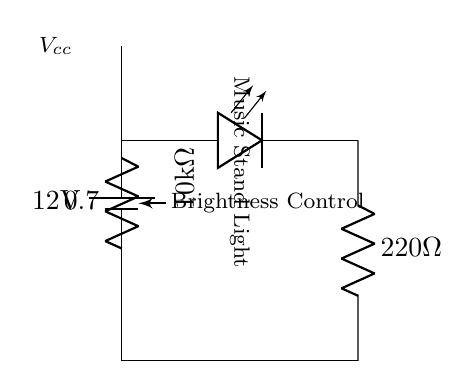What is the total voltage supplied to the circuit? The total voltage supplied to the circuit by the battery is indicated as 12 volts in the diagram.
Answer: 12 volts What type of component is used for brightness control? The component used for brightness control in this circuit is a potentiometer, specifically shown as a variable resistor, which allows adjustment of the current flowing to the LED.
Answer: Potentiometer What is the resistance value of the potentiometer? The resistance value of the potentiometer is labeled in the diagram as 10 kilo-ohms, indicating its adjustable range for the circuit.
Answer: 10 kilo-ohms Which component serves as the music stand light? The component that serves as the music stand light is represented as an LED in the circuit diagram, which emits light when current passes through it.
Answer: LED What is the resistance value of the resistor connected to the LED? The resistor connected to the LED is labeled as 220 ohms, which helps to limit the current flowing through the LED to prevent damage.
Answer: 220 ohms How does adjusting the potentiometer affect the LED brightness? Adjusting the potentiometer changes the resistance in the circuit, which in turn varies the current flowing through the LED; less resistance results in more current and brighter light, while more resistance decreases current and dims the light.
Answer: Changes LED brightness What is the purpose of the 220 ohm resistor in the circuit? The purpose of the 220 ohm resistor in this circuit is to limit the current to the LED, preventing it from exceeding its maximum rating and ensuring safe operation.
Answer: Current limiting 